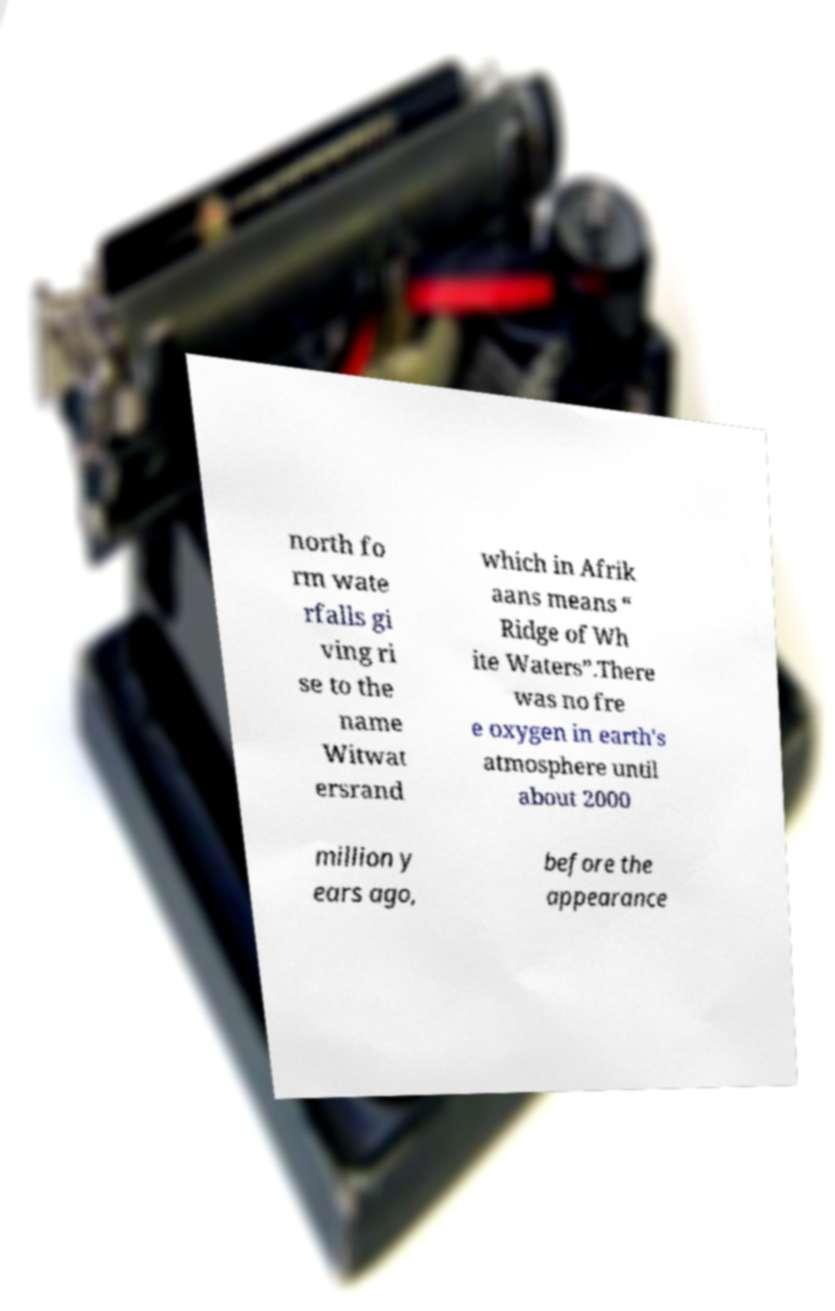Can you accurately transcribe the text from the provided image for me? north fo rm wate rfalls gi ving ri se to the name Witwat ersrand which in Afrik aans means “ Ridge of Wh ite Waters”.There was no fre e oxygen in earth's atmosphere until about 2000 million y ears ago, before the appearance 